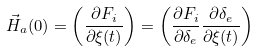<formula> <loc_0><loc_0><loc_500><loc_500>\vec { H } _ { a } ( 0 ) = \left ( \frac { \partial F _ { i } } { \partial \xi ( t ) } \right ) = \left ( \frac { \partial F _ { i } } { \partial \delta _ { e } } \frac { \partial \delta _ { e } } { \partial \xi ( t ) } \right )</formula> 